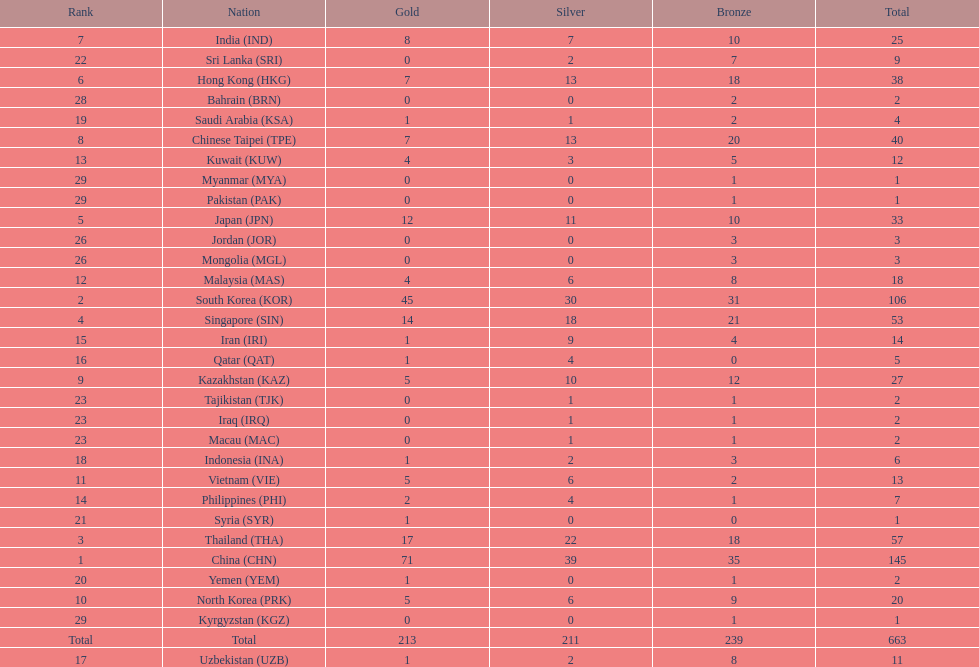Which nation has more gold medals, kuwait or india? India (IND). 